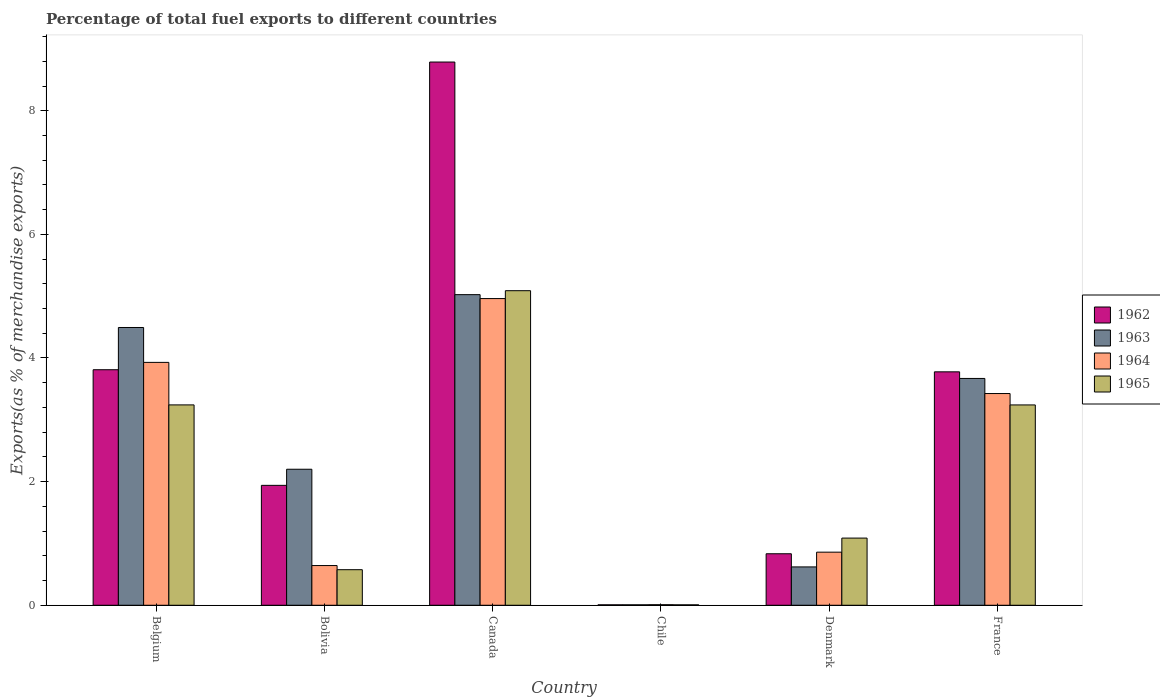How many groups of bars are there?
Offer a very short reply. 6. How many bars are there on the 1st tick from the left?
Provide a succinct answer. 4. What is the label of the 3rd group of bars from the left?
Offer a terse response. Canada. In how many cases, is the number of bars for a given country not equal to the number of legend labels?
Offer a terse response. 0. What is the percentage of exports to different countries in 1963 in France?
Provide a succinct answer. 3.67. Across all countries, what is the maximum percentage of exports to different countries in 1965?
Give a very brief answer. 5.09. Across all countries, what is the minimum percentage of exports to different countries in 1965?
Offer a terse response. 0.01. What is the total percentage of exports to different countries in 1965 in the graph?
Your response must be concise. 13.24. What is the difference between the percentage of exports to different countries in 1962 in Belgium and that in Chile?
Provide a short and direct response. 3.8. What is the difference between the percentage of exports to different countries in 1962 in Canada and the percentage of exports to different countries in 1965 in France?
Ensure brevity in your answer.  5.55. What is the average percentage of exports to different countries in 1965 per country?
Make the answer very short. 2.21. What is the difference between the percentage of exports to different countries of/in 1965 and percentage of exports to different countries of/in 1962 in Chile?
Offer a terse response. -0. In how many countries, is the percentage of exports to different countries in 1963 greater than 4.8 %?
Keep it short and to the point. 1. What is the ratio of the percentage of exports to different countries in 1964 in Chile to that in France?
Give a very brief answer. 0. Is the difference between the percentage of exports to different countries in 1965 in Bolivia and Denmark greater than the difference between the percentage of exports to different countries in 1962 in Bolivia and Denmark?
Ensure brevity in your answer.  No. What is the difference between the highest and the second highest percentage of exports to different countries in 1964?
Give a very brief answer. -0.5. What is the difference between the highest and the lowest percentage of exports to different countries in 1963?
Offer a very short reply. 5.02. What does the 2nd bar from the left in Bolivia represents?
Provide a succinct answer. 1963. What does the 2nd bar from the right in Bolivia represents?
Your response must be concise. 1964. Is it the case that in every country, the sum of the percentage of exports to different countries in 1962 and percentage of exports to different countries in 1964 is greater than the percentage of exports to different countries in 1965?
Ensure brevity in your answer.  Yes. How many bars are there?
Your answer should be very brief. 24. Are all the bars in the graph horizontal?
Your answer should be very brief. No. How are the legend labels stacked?
Provide a succinct answer. Vertical. What is the title of the graph?
Make the answer very short. Percentage of total fuel exports to different countries. What is the label or title of the X-axis?
Offer a very short reply. Country. What is the label or title of the Y-axis?
Your answer should be very brief. Exports(as % of merchandise exports). What is the Exports(as % of merchandise exports) of 1962 in Belgium?
Make the answer very short. 3.81. What is the Exports(as % of merchandise exports) in 1963 in Belgium?
Give a very brief answer. 4.49. What is the Exports(as % of merchandise exports) in 1964 in Belgium?
Provide a succinct answer. 3.93. What is the Exports(as % of merchandise exports) in 1965 in Belgium?
Your answer should be compact. 3.24. What is the Exports(as % of merchandise exports) in 1962 in Bolivia?
Keep it short and to the point. 1.94. What is the Exports(as % of merchandise exports) in 1963 in Bolivia?
Make the answer very short. 2.2. What is the Exports(as % of merchandise exports) of 1964 in Bolivia?
Ensure brevity in your answer.  0.64. What is the Exports(as % of merchandise exports) of 1965 in Bolivia?
Provide a short and direct response. 0.58. What is the Exports(as % of merchandise exports) in 1962 in Canada?
Keep it short and to the point. 8.79. What is the Exports(as % of merchandise exports) of 1963 in Canada?
Make the answer very short. 5.02. What is the Exports(as % of merchandise exports) in 1964 in Canada?
Your answer should be compact. 4.96. What is the Exports(as % of merchandise exports) in 1965 in Canada?
Ensure brevity in your answer.  5.09. What is the Exports(as % of merchandise exports) in 1962 in Chile?
Give a very brief answer. 0.01. What is the Exports(as % of merchandise exports) of 1963 in Chile?
Your answer should be very brief. 0.01. What is the Exports(as % of merchandise exports) of 1964 in Chile?
Provide a succinct answer. 0.01. What is the Exports(as % of merchandise exports) in 1965 in Chile?
Provide a succinct answer. 0.01. What is the Exports(as % of merchandise exports) of 1962 in Denmark?
Give a very brief answer. 0.83. What is the Exports(as % of merchandise exports) of 1963 in Denmark?
Keep it short and to the point. 0.62. What is the Exports(as % of merchandise exports) of 1964 in Denmark?
Give a very brief answer. 0.86. What is the Exports(as % of merchandise exports) in 1965 in Denmark?
Your response must be concise. 1.09. What is the Exports(as % of merchandise exports) of 1962 in France?
Make the answer very short. 3.78. What is the Exports(as % of merchandise exports) of 1963 in France?
Your answer should be very brief. 3.67. What is the Exports(as % of merchandise exports) of 1964 in France?
Give a very brief answer. 3.43. What is the Exports(as % of merchandise exports) in 1965 in France?
Ensure brevity in your answer.  3.24. Across all countries, what is the maximum Exports(as % of merchandise exports) in 1962?
Give a very brief answer. 8.79. Across all countries, what is the maximum Exports(as % of merchandise exports) in 1963?
Your answer should be compact. 5.02. Across all countries, what is the maximum Exports(as % of merchandise exports) of 1964?
Your response must be concise. 4.96. Across all countries, what is the maximum Exports(as % of merchandise exports) of 1965?
Offer a very short reply. 5.09. Across all countries, what is the minimum Exports(as % of merchandise exports) of 1962?
Provide a short and direct response. 0.01. Across all countries, what is the minimum Exports(as % of merchandise exports) in 1963?
Provide a succinct answer. 0.01. Across all countries, what is the minimum Exports(as % of merchandise exports) of 1964?
Your answer should be compact. 0.01. Across all countries, what is the minimum Exports(as % of merchandise exports) in 1965?
Ensure brevity in your answer.  0.01. What is the total Exports(as % of merchandise exports) of 1962 in the graph?
Offer a very short reply. 19.15. What is the total Exports(as % of merchandise exports) in 1963 in the graph?
Make the answer very short. 16.02. What is the total Exports(as % of merchandise exports) in 1964 in the graph?
Ensure brevity in your answer.  13.83. What is the total Exports(as % of merchandise exports) of 1965 in the graph?
Your response must be concise. 13.24. What is the difference between the Exports(as % of merchandise exports) in 1962 in Belgium and that in Bolivia?
Offer a terse response. 1.87. What is the difference between the Exports(as % of merchandise exports) in 1963 in Belgium and that in Bolivia?
Your response must be concise. 2.29. What is the difference between the Exports(as % of merchandise exports) of 1964 in Belgium and that in Bolivia?
Provide a succinct answer. 3.29. What is the difference between the Exports(as % of merchandise exports) of 1965 in Belgium and that in Bolivia?
Give a very brief answer. 2.67. What is the difference between the Exports(as % of merchandise exports) in 1962 in Belgium and that in Canada?
Ensure brevity in your answer.  -4.98. What is the difference between the Exports(as % of merchandise exports) of 1963 in Belgium and that in Canada?
Your answer should be very brief. -0.53. What is the difference between the Exports(as % of merchandise exports) in 1964 in Belgium and that in Canada?
Ensure brevity in your answer.  -1.03. What is the difference between the Exports(as % of merchandise exports) in 1965 in Belgium and that in Canada?
Offer a very short reply. -1.85. What is the difference between the Exports(as % of merchandise exports) of 1962 in Belgium and that in Chile?
Offer a terse response. 3.8. What is the difference between the Exports(as % of merchandise exports) in 1963 in Belgium and that in Chile?
Provide a succinct answer. 4.49. What is the difference between the Exports(as % of merchandise exports) of 1964 in Belgium and that in Chile?
Your response must be concise. 3.92. What is the difference between the Exports(as % of merchandise exports) of 1965 in Belgium and that in Chile?
Keep it short and to the point. 3.23. What is the difference between the Exports(as % of merchandise exports) in 1962 in Belgium and that in Denmark?
Give a very brief answer. 2.98. What is the difference between the Exports(as % of merchandise exports) in 1963 in Belgium and that in Denmark?
Give a very brief answer. 3.87. What is the difference between the Exports(as % of merchandise exports) in 1964 in Belgium and that in Denmark?
Offer a terse response. 3.07. What is the difference between the Exports(as % of merchandise exports) of 1965 in Belgium and that in Denmark?
Your response must be concise. 2.15. What is the difference between the Exports(as % of merchandise exports) in 1962 in Belgium and that in France?
Give a very brief answer. 0.03. What is the difference between the Exports(as % of merchandise exports) of 1963 in Belgium and that in France?
Your response must be concise. 0.82. What is the difference between the Exports(as % of merchandise exports) of 1964 in Belgium and that in France?
Keep it short and to the point. 0.5. What is the difference between the Exports(as % of merchandise exports) in 1962 in Bolivia and that in Canada?
Your answer should be very brief. -6.85. What is the difference between the Exports(as % of merchandise exports) in 1963 in Bolivia and that in Canada?
Your response must be concise. -2.82. What is the difference between the Exports(as % of merchandise exports) in 1964 in Bolivia and that in Canada?
Ensure brevity in your answer.  -4.32. What is the difference between the Exports(as % of merchandise exports) of 1965 in Bolivia and that in Canada?
Make the answer very short. -4.51. What is the difference between the Exports(as % of merchandise exports) of 1962 in Bolivia and that in Chile?
Offer a terse response. 1.93. What is the difference between the Exports(as % of merchandise exports) in 1963 in Bolivia and that in Chile?
Ensure brevity in your answer.  2.19. What is the difference between the Exports(as % of merchandise exports) in 1964 in Bolivia and that in Chile?
Make the answer very short. 0.63. What is the difference between the Exports(as % of merchandise exports) in 1965 in Bolivia and that in Chile?
Your response must be concise. 0.57. What is the difference between the Exports(as % of merchandise exports) of 1962 in Bolivia and that in Denmark?
Make the answer very short. 1.11. What is the difference between the Exports(as % of merchandise exports) of 1963 in Bolivia and that in Denmark?
Provide a succinct answer. 1.58. What is the difference between the Exports(as % of merchandise exports) of 1964 in Bolivia and that in Denmark?
Provide a succinct answer. -0.22. What is the difference between the Exports(as % of merchandise exports) of 1965 in Bolivia and that in Denmark?
Ensure brevity in your answer.  -0.51. What is the difference between the Exports(as % of merchandise exports) in 1962 in Bolivia and that in France?
Provide a succinct answer. -1.84. What is the difference between the Exports(as % of merchandise exports) in 1963 in Bolivia and that in France?
Give a very brief answer. -1.47. What is the difference between the Exports(as % of merchandise exports) of 1964 in Bolivia and that in France?
Give a very brief answer. -2.78. What is the difference between the Exports(as % of merchandise exports) in 1965 in Bolivia and that in France?
Your answer should be compact. -2.67. What is the difference between the Exports(as % of merchandise exports) in 1962 in Canada and that in Chile?
Offer a terse response. 8.78. What is the difference between the Exports(as % of merchandise exports) of 1963 in Canada and that in Chile?
Provide a short and direct response. 5.02. What is the difference between the Exports(as % of merchandise exports) of 1964 in Canada and that in Chile?
Keep it short and to the point. 4.95. What is the difference between the Exports(as % of merchandise exports) in 1965 in Canada and that in Chile?
Your response must be concise. 5.08. What is the difference between the Exports(as % of merchandise exports) in 1962 in Canada and that in Denmark?
Ensure brevity in your answer.  7.95. What is the difference between the Exports(as % of merchandise exports) in 1963 in Canada and that in Denmark?
Provide a succinct answer. 4.4. What is the difference between the Exports(as % of merchandise exports) in 1964 in Canada and that in Denmark?
Your answer should be compact. 4.1. What is the difference between the Exports(as % of merchandise exports) in 1965 in Canada and that in Denmark?
Provide a succinct answer. 4. What is the difference between the Exports(as % of merchandise exports) in 1962 in Canada and that in France?
Your answer should be very brief. 5.01. What is the difference between the Exports(as % of merchandise exports) in 1963 in Canada and that in France?
Make the answer very short. 1.36. What is the difference between the Exports(as % of merchandise exports) of 1964 in Canada and that in France?
Provide a succinct answer. 1.54. What is the difference between the Exports(as % of merchandise exports) in 1965 in Canada and that in France?
Your response must be concise. 1.85. What is the difference between the Exports(as % of merchandise exports) in 1962 in Chile and that in Denmark?
Keep it short and to the point. -0.83. What is the difference between the Exports(as % of merchandise exports) in 1963 in Chile and that in Denmark?
Ensure brevity in your answer.  -0.61. What is the difference between the Exports(as % of merchandise exports) in 1964 in Chile and that in Denmark?
Provide a succinct answer. -0.85. What is the difference between the Exports(as % of merchandise exports) in 1965 in Chile and that in Denmark?
Ensure brevity in your answer.  -1.08. What is the difference between the Exports(as % of merchandise exports) of 1962 in Chile and that in France?
Make the answer very short. -3.77. What is the difference between the Exports(as % of merchandise exports) in 1963 in Chile and that in France?
Give a very brief answer. -3.66. What is the difference between the Exports(as % of merchandise exports) of 1964 in Chile and that in France?
Give a very brief answer. -3.42. What is the difference between the Exports(as % of merchandise exports) of 1965 in Chile and that in France?
Your answer should be compact. -3.23. What is the difference between the Exports(as % of merchandise exports) of 1962 in Denmark and that in France?
Your answer should be very brief. -2.94. What is the difference between the Exports(as % of merchandise exports) of 1963 in Denmark and that in France?
Give a very brief answer. -3.05. What is the difference between the Exports(as % of merchandise exports) of 1964 in Denmark and that in France?
Provide a succinct answer. -2.57. What is the difference between the Exports(as % of merchandise exports) of 1965 in Denmark and that in France?
Offer a very short reply. -2.15. What is the difference between the Exports(as % of merchandise exports) of 1962 in Belgium and the Exports(as % of merchandise exports) of 1963 in Bolivia?
Ensure brevity in your answer.  1.61. What is the difference between the Exports(as % of merchandise exports) of 1962 in Belgium and the Exports(as % of merchandise exports) of 1964 in Bolivia?
Provide a short and direct response. 3.17. What is the difference between the Exports(as % of merchandise exports) in 1962 in Belgium and the Exports(as % of merchandise exports) in 1965 in Bolivia?
Provide a succinct answer. 3.23. What is the difference between the Exports(as % of merchandise exports) in 1963 in Belgium and the Exports(as % of merchandise exports) in 1964 in Bolivia?
Your answer should be compact. 3.85. What is the difference between the Exports(as % of merchandise exports) of 1963 in Belgium and the Exports(as % of merchandise exports) of 1965 in Bolivia?
Your answer should be very brief. 3.92. What is the difference between the Exports(as % of merchandise exports) of 1964 in Belgium and the Exports(as % of merchandise exports) of 1965 in Bolivia?
Your answer should be very brief. 3.35. What is the difference between the Exports(as % of merchandise exports) of 1962 in Belgium and the Exports(as % of merchandise exports) of 1963 in Canada?
Your answer should be very brief. -1.21. What is the difference between the Exports(as % of merchandise exports) of 1962 in Belgium and the Exports(as % of merchandise exports) of 1964 in Canada?
Your response must be concise. -1.15. What is the difference between the Exports(as % of merchandise exports) in 1962 in Belgium and the Exports(as % of merchandise exports) in 1965 in Canada?
Offer a very short reply. -1.28. What is the difference between the Exports(as % of merchandise exports) in 1963 in Belgium and the Exports(as % of merchandise exports) in 1964 in Canada?
Your response must be concise. -0.47. What is the difference between the Exports(as % of merchandise exports) in 1963 in Belgium and the Exports(as % of merchandise exports) in 1965 in Canada?
Provide a succinct answer. -0.6. What is the difference between the Exports(as % of merchandise exports) in 1964 in Belgium and the Exports(as % of merchandise exports) in 1965 in Canada?
Provide a short and direct response. -1.16. What is the difference between the Exports(as % of merchandise exports) of 1962 in Belgium and the Exports(as % of merchandise exports) of 1963 in Chile?
Your answer should be very brief. 3.8. What is the difference between the Exports(as % of merchandise exports) in 1962 in Belgium and the Exports(as % of merchandise exports) in 1964 in Chile?
Offer a very short reply. 3.8. What is the difference between the Exports(as % of merchandise exports) in 1962 in Belgium and the Exports(as % of merchandise exports) in 1965 in Chile?
Make the answer very short. 3.8. What is the difference between the Exports(as % of merchandise exports) in 1963 in Belgium and the Exports(as % of merchandise exports) in 1964 in Chile?
Make the answer very short. 4.48. What is the difference between the Exports(as % of merchandise exports) of 1963 in Belgium and the Exports(as % of merchandise exports) of 1965 in Chile?
Offer a very short reply. 4.49. What is the difference between the Exports(as % of merchandise exports) in 1964 in Belgium and the Exports(as % of merchandise exports) in 1965 in Chile?
Your response must be concise. 3.92. What is the difference between the Exports(as % of merchandise exports) of 1962 in Belgium and the Exports(as % of merchandise exports) of 1963 in Denmark?
Provide a short and direct response. 3.19. What is the difference between the Exports(as % of merchandise exports) of 1962 in Belgium and the Exports(as % of merchandise exports) of 1964 in Denmark?
Offer a very short reply. 2.95. What is the difference between the Exports(as % of merchandise exports) of 1962 in Belgium and the Exports(as % of merchandise exports) of 1965 in Denmark?
Your response must be concise. 2.72. What is the difference between the Exports(as % of merchandise exports) in 1963 in Belgium and the Exports(as % of merchandise exports) in 1964 in Denmark?
Provide a short and direct response. 3.63. What is the difference between the Exports(as % of merchandise exports) in 1963 in Belgium and the Exports(as % of merchandise exports) in 1965 in Denmark?
Your answer should be compact. 3.41. What is the difference between the Exports(as % of merchandise exports) in 1964 in Belgium and the Exports(as % of merchandise exports) in 1965 in Denmark?
Your response must be concise. 2.84. What is the difference between the Exports(as % of merchandise exports) in 1962 in Belgium and the Exports(as % of merchandise exports) in 1963 in France?
Offer a terse response. 0.14. What is the difference between the Exports(as % of merchandise exports) of 1962 in Belgium and the Exports(as % of merchandise exports) of 1964 in France?
Offer a terse response. 0.39. What is the difference between the Exports(as % of merchandise exports) in 1962 in Belgium and the Exports(as % of merchandise exports) in 1965 in France?
Ensure brevity in your answer.  0.57. What is the difference between the Exports(as % of merchandise exports) of 1963 in Belgium and the Exports(as % of merchandise exports) of 1964 in France?
Offer a terse response. 1.07. What is the difference between the Exports(as % of merchandise exports) in 1963 in Belgium and the Exports(as % of merchandise exports) in 1965 in France?
Your answer should be very brief. 1.25. What is the difference between the Exports(as % of merchandise exports) of 1964 in Belgium and the Exports(as % of merchandise exports) of 1965 in France?
Offer a very short reply. 0.69. What is the difference between the Exports(as % of merchandise exports) in 1962 in Bolivia and the Exports(as % of merchandise exports) in 1963 in Canada?
Keep it short and to the point. -3.08. What is the difference between the Exports(as % of merchandise exports) in 1962 in Bolivia and the Exports(as % of merchandise exports) in 1964 in Canada?
Make the answer very short. -3.02. What is the difference between the Exports(as % of merchandise exports) of 1962 in Bolivia and the Exports(as % of merchandise exports) of 1965 in Canada?
Your response must be concise. -3.15. What is the difference between the Exports(as % of merchandise exports) in 1963 in Bolivia and the Exports(as % of merchandise exports) in 1964 in Canada?
Your answer should be very brief. -2.76. What is the difference between the Exports(as % of merchandise exports) of 1963 in Bolivia and the Exports(as % of merchandise exports) of 1965 in Canada?
Provide a succinct answer. -2.89. What is the difference between the Exports(as % of merchandise exports) in 1964 in Bolivia and the Exports(as % of merchandise exports) in 1965 in Canada?
Provide a short and direct response. -4.45. What is the difference between the Exports(as % of merchandise exports) of 1962 in Bolivia and the Exports(as % of merchandise exports) of 1963 in Chile?
Ensure brevity in your answer.  1.93. What is the difference between the Exports(as % of merchandise exports) in 1962 in Bolivia and the Exports(as % of merchandise exports) in 1964 in Chile?
Make the answer very short. 1.93. What is the difference between the Exports(as % of merchandise exports) in 1962 in Bolivia and the Exports(as % of merchandise exports) in 1965 in Chile?
Offer a terse response. 1.93. What is the difference between the Exports(as % of merchandise exports) of 1963 in Bolivia and the Exports(as % of merchandise exports) of 1964 in Chile?
Your answer should be very brief. 2.19. What is the difference between the Exports(as % of merchandise exports) of 1963 in Bolivia and the Exports(as % of merchandise exports) of 1965 in Chile?
Ensure brevity in your answer.  2.19. What is the difference between the Exports(as % of merchandise exports) in 1964 in Bolivia and the Exports(as % of merchandise exports) in 1965 in Chile?
Keep it short and to the point. 0.64. What is the difference between the Exports(as % of merchandise exports) in 1962 in Bolivia and the Exports(as % of merchandise exports) in 1963 in Denmark?
Your answer should be compact. 1.32. What is the difference between the Exports(as % of merchandise exports) in 1962 in Bolivia and the Exports(as % of merchandise exports) in 1964 in Denmark?
Give a very brief answer. 1.08. What is the difference between the Exports(as % of merchandise exports) in 1962 in Bolivia and the Exports(as % of merchandise exports) in 1965 in Denmark?
Your answer should be very brief. 0.85. What is the difference between the Exports(as % of merchandise exports) in 1963 in Bolivia and the Exports(as % of merchandise exports) in 1964 in Denmark?
Provide a short and direct response. 1.34. What is the difference between the Exports(as % of merchandise exports) in 1963 in Bolivia and the Exports(as % of merchandise exports) in 1965 in Denmark?
Your answer should be compact. 1.11. What is the difference between the Exports(as % of merchandise exports) in 1964 in Bolivia and the Exports(as % of merchandise exports) in 1965 in Denmark?
Your answer should be very brief. -0.44. What is the difference between the Exports(as % of merchandise exports) of 1962 in Bolivia and the Exports(as % of merchandise exports) of 1963 in France?
Provide a short and direct response. -1.73. What is the difference between the Exports(as % of merchandise exports) of 1962 in Bolivia and the Exports(as % of merchandise exports) of 1964 in France?
Your answer should be very brief. -1.49. What is the difference between the Exports(as % of merchandise exports) of 1962 in Bolivia and the Exports(as % of merchandise exports) of 1965 in France?
Offer a very short reply. -1.3. What is the difference between the Exports(as % of merchandise exports) in 1963 in Bolivia and the Exports(as % of merchandise exports) in 1964 in France?
Keep it short and to the point. -1.22. What is the difference between the Exports(as % of merchandise exports) of 1963 in Bolivia and the Exports(as % of merchandise exports) of 1965 in France?
Offer a very short reply. -1.04. What is the difference between the Exports(as % of merchandise exports) of 1964 in Bolivia and the Exports(as % of merchandise exports) of 1965 in France?
Your response must be concise. -2.6. What is the difference between the Exports(as % of merchandise exports) of 1962 in Canada and the Exports(as % of merchandise exports) of 1963 in Chile?
Give a very brief answer. 8.78. What is the difference between the Exports(as % of merchandise exports) of 1962 in Canada and the Exports(as % of merchandise exports) of 1964 in Chile?
Ensure brevity in your answer.  8.78. What is the difference between the Exports(as % of merchandise exports) in 1962 in Canada and the Exports(as % of merchandise exports) in 1965 in Chile?
Provide a short and direct response. 8.78. What is the difference between the Exports(as % of merchandise exports) in 1963 in Canada and the Exports(as % of merchandise exports) in 1964 in Chile?
Provide a succinct answer. 5.02. What is the difference between the Exports(as % of merchandise exports) of 1963 in Canada and the Exports(as % of merchandise exports) of 1965 in Chile?
Provide a short and direct response. 5.02. What is the difference between the Exports(as % of merchandise exports) of 1964 in Canada and the Exports(as % of merchandise exports) of 1965 in Chile?
Make the answer very short. 4.95. What is the difference between the Exports(as % of merchandise exports) of 1962 in Canada and the Exports(as % of merchandise exports) of 1963 in Denmark?
Offer a very short reply. 8.17. What is the difference between the Exports(as % of merchandise exports) in 1962 in Canada and the Exports(as % of merchandise exports) in 1964 in Denmark?
Provide a short and direct response. 7.93. What is the difference between the Exports(as % of merchandise exports) of 1962 in Canada and the Exports(as % of merchandise exports) of 1965 in Denmark?
Keep it short and to the point. 7.7. What is the difference between the Exports(as % of merchandise exports) of 1963 in Canada and the Exports(as % of merchandise exports) of 1964 in Denmark?
Make the answer very short. 4.17. What is the difference between the Exports(as % of merchandise exports) of 1963 in Canada and the Exports(as % of merchandise exports) of 1965 in Denmark?
Your answer should be compact. 3.94. What is the difference between the Exports(as % of merchandise exports) in 1964 in Canada and the Exports(as % of merchandise exports) in 1965 in Denmark?
Make the answer very short. 3.87. What is the difference between the Exports(as % of merchandise exports) in 1962 in Canada and the Exports(as % of merchandise exports) in 1963 in France?
Your answer should be very brief. 5.12. What is the difference between the Exports(as % of merchandise exports) in 1962 in Canada and the Exports(as % of merchandise exports) in 1964 in France?
Provide a succinct answer. 5.36. What is the difference between the Exports(as % of merchandise exports) in 1962 in Canada and the Exports(as % of merchandise exports) in 1965 in France?
Provide a short and direct response. 5.55. What is the difference between the Exports(as % of merchandise exports) of 1963 in Canada and the Exports(as % of merchandise exports) of 1964 in France?
Give a very brief answer. 1.6. What is the difference between the Exports(as % of merchandise exports) of 1963 in Canada and the Exports(as % of merchandise exports) of 1965 in France?
Your response must be concise. 1.78. What is the difference between the Exports(as % of merchandise exports) of 1964 in Canada and the Exports(as % of merchandise exports) of 1965 in France?
Keep it short and to the point. 1.72. What is the difference between the Exports(as % of merchandise exports) of 1962 in Chile and the Exports(as % of merchandise exports) of 1963 in Denmark?
Your answer should be very brief. -0.61. What is the difference between the Exports(as % of merchandise exports) of 1962 in Chile and the Exports(as % of merchandise exports) of 1964 in Denmark?
Offer a terse response. -0.85. What is the difference between the Exports(as % of merchandise exports) in 1962 in Chile and the Exports(as % of merchandise exports) in 1965 in Denmark?
Offer a terse response. -1.08. What is the difference between the Exports(as % of merchandise exports) of 1963 in Chile and the Exports(as % of merchandise exports) of 1964 in Denmark?
Give a very brief answer. -0.85. What is the difference between the Exports(as % of merchandise exports) of 1963 in Chile and the Exports(as % of merchandise exports) of 1965 in Denmark?
Keep it short and to the point. -1.08. What is the difference between the Exports(as % of merchandise exports) of 1964 in Chile and the Exports(as % of merchandise exports) of 1965 in Denmark?
Offer a very short reply. -1.08. What is the difference between the Exports(as % of merchandise exports) of 1962 in Chile and the Exports(as % of merchandise exports) of 1963 in France?
Keep it short and to the point. -3.66. What is the difference between the Exports(as % of merchandise exports) of 1962 in Chile and the Exports(as % of merchandise exports) of 1964 in France?
Ensure brevity in your answer.  -3.42. What is the difference between the Exports(as % of merchandise exports) of 1962 in Chile and the Exports(as % of merchandise exports) of 1965 in France?
Provide a short and direct response. -3.23. What is the difference between the Exports(as % of merchandise exports) of 1963 in Chile and the Exports(as % of merchandise exports) of 1964 in France?
Provide a short and direct response. -3.42. What is the difference between the Exports(as % of merchandise exports) in 1963 in Chile and the Exports(as % of merchandise exports) in 1965 in France?
Keep it short and to the point. -3.23. What is the difference between the Exports(as % of merchandise exports) in 1964 in Chile and the Exports(as % of merchandise exports) in 1965 in France?
Offer a terse response. -3.23. What is the difference between the Exports(as % of merchandise exports) of 1962 in Denmark and the Exports(as % of merchandise exports) of 1963 in France?
Your response must be concise. -2.84. What is the difference between the Exports(as % of merchandise exports) of 1962 in Denmark and the Exports(as % of merchandise exports) of 1964 in France?
Give a very brief answer. -2.59. What is the difference between the Exports(as % of merchandise exports) of 1962 in Denmark and the Exports(as % of merchandise exports) of 1965 in France?
Your answer should be compact. -2.41. What is the difference between the Exports(as % of merchandise exports) of 1963 in Denmark and the Exports(as % of merchandise exports) of 1964 in France?
Provide a short and direct response. -2.8. What is the difference between the Exports(as % of merchandise exports) of 1963 in Denmark and the Exports(as % of merchandise exports) of 1965 in France?
Ensure brevity in your answer.  -2.62. What is the difference between the Exports(as % of merchandise exports) in 1964 in Denmark and the Exports(as % of merchandise exports) in 1965 in France?
Offer a very short reply. -2.38. What is the average Exports(as % of merchandise exports) of 1962 per country?
Keep it short and to the point. 3.19. What is the average Exports(as % of merchandise exports) in 1963 per country?
Ensure brevity in your answer.  2.67. What is the average Exports(as % of merchandise exports) of 1964 per country?
Keep it short and to the point. 2.3. What is the average Exports(as % of merchandise exports) of 1965 per country?
Ensure brevity in your answer.  2.21. What is the difference between the Exports(as % of merchandise exports) of 1962 and Exports(as % of merchandise exports) of 1963 in Belgium?
Ensure brevity in your answer.  -0.68. What is the difference between the Exports(as % of merchandise exports) in 1962 and Exports(as % of merchandise exports) in 1964 in Belgium?
Offer a very short reply. -0.12. What is the difference between the Exports(as % of merchandise exports) in 1962 and Exports(as % of merchandise exports) in 1965 in Belgium?
Make the answer very short. 0.57. What is the difference between the Exports(as % of merchandise exports) of 1963 and Exports(as % of merchandise exports) of 1964 in Belgium?
Provide a short and direct response. 0.56. What is the difference between the Exports(as % of merchandise exports) of 1963 and Exports(as % of merchandise exports) of 1965 in Belgium?
Offer a very short reply. 1.25. What is the difference between the Exports(as % of merchandise exports) in 1964 and Exports(as % of merchandise exports) in 1965 in Belgium?
Make the answer very short. 0.69. What is the difference between the Exports(as % of merchandise exports) in 1962 and Exports(as % of merchandise exports) in 1963 in Bolivia?
Make the answer very short. -0.26. What is the difference between the Exports(as % of merchandise exports) in 1962 and Exports(as % of merchandise exports) in 1964 in Bolivia?
Give a very brief answer. 1.3. What is the difference between the Exports(as % of merchandise exports) of 1962 and Exports(as % of merchandise exports) of 1965 in Bolivia?
Your answer should be very brief. 1.36. What is the difference between the Exports(as % of merchandise exports) in 1963 and Exports(as % of merchandise exports) in 1964 in Bolivia?
Keep it short and to the point. 1.56. What is the difference between the Exports(as % of merchandise exports) of 1963 and Exports(as % of merchandise exports) of 1965 in Bolivia?
Your answer should be very brief. 1.62. What is the difference between the Exports(as % of merchandise exports) of 1964 and Exports(as % of merchandise exports) of 1965 in Bolivia?
Offer a very short reply. 0.07. What is the difference between the Exports(as % of merchandise exports) of 1962 and Exports(as % of merchandise exports) of 1963 in Canada?
Make the answer very short. 3.76. What is the difference between the Exports(as % of merchandise exports) in 1962 and Exports(as % of merchandise exports) in 1964 in Canada?
Offer a terse response. 3.83. What is the difference between the Exports(as % of merchandise exports) of 1962 and Exports(as % of merchandise exports) of 1965 in Canada?
Provide a succinct answer. 3.7. What is the difference between the Exports(as % of merchandise exports) of 1963 and Exports(as % of merchandise exports) of 1964 in Canada?
Your answer should be compact. 0.06. What is the difference between the Exports(as % of merchandise exports) in 1963 and Exports(as % of merchandise exports) in 1965 in Canada?
Offer a terse response. -0.06. What is the difference between the Exports(as % of merchandise exports) in 1964 and Exports(as % of merchandise exports) in 1965 in Canada?
Keep it short and to the point. -0.13. What is the difference between the Exports(as % of merchandise exports) in 1962 and Exports(as % of merchandise exports) in 1963 in Chile?
Your answer should be very brief. -0. What is the difference between the Exports(as % of merchandise exports) in 1962 and Exports(as % of merchandise exports) in 1964 in Chile?
Make the answer very short. -0. What is the difference between the Exports(as % of merchandise exports) of 1962 and Exports(as % of merchandise exports) of 1965 in Chile?
Ensure brevity in your answer.  0. What is the difference between the Exports(as % of merchandise exports) of 1963 and Exports(as % of merchandise exports) of 1964 in Chile?
Ensure brevity in your answer.  -0. What is the difference between the Exports(as % of merchandise exports) in 1963 and Exports(as % of merchandise exports) in 1965 in Chile?
Make the answer very short. 0. What is the difference between the Exports(as % of merchandise exports) of 1964 and Exports(as % of merchandise exports) of 1965 in Chile?
Your answer should be compact. 0. What is the difference between the Exports(as % of merchandise exports) of 1962 and Exports(as % of merchandise exports) of 1963 in Denmark?
Provide a succinct answer. 0.21. What is the difference between the Exports(as % of merchandise exports) in 1962 and Exports(as % of merchandise exports) in 1964 in Denmark?
Keep it short and to the point. -0.03. What is the difference between the Exports(as % of merchandise exports) of 1962 and Exports(as % of merchandise exports) of 1965 in Denmark?
Keep it short and to the point. -0.25. What is the difference between the Exports(as % of merchandise exports) in 1963 and Exports(as % of merchandise exports) in 1964 in Denmark?
Give a very brief answer. -0.24. What is the difference between the Exports(as % of merchandise exports) of 1963 and Exports(as % of merchandise exports) of 1965 in Denmark?
Ensure brevity in your answer.  -0.47. What is the difference between the Exports(as % of merchandise exports) of 1964 and Exports(as % of merchandise exports) of 1965 in Denmark?
Give a very brief answer. -0.23. What is the difference between the Exports(as % of merchandise exports) of 1962 and Exports(as % of merchandise exports) of 1963 in France?
Provide a succinct answer. 0.11. What is the difference between the Exports(as % of merchandise exports) of 1962 and Exports(as % of merchandise exports) of 1964 in France?
Provide a succinct answer. 0.35. What is the difference between the Exports(as % of merchandise exports) in 1962 and Exports(as % of merchandise exports) in 1965 in France?
Your response must be concise. 0.54. What is the difference between the Exports(as % of merchandise exports) in 1963 and Exports(as % of merchandise exports) in 1964 in France?
Your answer should be very brief. 0.24. What is the difference between the Exports(as % of merchandise exports) in 1963 and Exports(as % of merchandise exports) in 1965 in France?
Offer a terse response. 0.43. What is the difference between the Exports(as % of merchandise exports) in 1964 and Exports(as % of merchandise exports) in 1965 in France?
Give a very brief answer. 0.18. What is the ratio of the Exports(as % of merchandise exports) in 1962 in Belgium to that in Bolivia?
Your answer should be very brief. 1.96. What is the ratio of the Exports(as % of merchandise exports) in 1963 in Belgium to that in Bolivia?
Offer a very short reply. 2.04. What is the ratio of the Exports(as % of merchandise exports) in 1964 in Belgium to that in Bolivia?
Offer a terse response. 6.12. What is the ratio of the Exports(as % of merchandise exports) in 1965 in Belgium to that in Bolivia?
Ensure brevity in your answer.  5.63. What is the ratio of the Exports(as % of merchandise exports) in 1962 in Belgium to that in Canada?
Offer a very short reply. 0.43. What is the ratio of the Exports(as % of merchandise exports) of 1963 in Belgium to that in Canada?
Make the answer very short. 0.89. What is the ratio of the Exports(as % of merchandise exports) of 1964 in Belgium to that in Canada?
Offer a very short reply. 0.79. What is the ratio of the Exports(as % of merchandise exports) in 1965 in Belgium to that in Canada?
Your answer should be compact. 0.64. What is the ratio of the Exports(as % of merchandise exports) of 1962 in Belgium to that in Chile?
Your response must be concise. 543.89. What is the ratio of the Exports(as % of merchandise exports) in 1963 in Belgium to that in Chile?
Your answer should be compact. 634.23. What is the ratio of the Exports(as % of merchandise exports) of 1964 in Belgium to that in Chile?
Keep it short and to the point. 439.88. What is the ratio of the Exports(as % of merchandise exports) of 1965 in Belgium to that in Chile?
Provide a succinct answer. 479.5. What is the ratio of the Exports(as % of merchandise exports) of 1962 in Belgium to that in Denmark?
Offer a very short reply. 4.57. What is the ratio of the Exports(as % of merchandise exports) of 1963 in Belgium to that in Denmark?
Give a very brief answer. 7.24. What is the ratio of the Exports(as % of merchandise exports) of 1964 in Belgium to that in Denmark?
Your answer should be very brief. 4.57. What is the ratio of the Exports(as % of merchandise exports) in 1965 in Belgium to that in Denmark?
Provide a short and direct response. 2.98. What is the ratio of the Exports(as % of merchandise exports) in 1962 in Belgium to that in France?
Provide a short and direct response. 1.01. What is the ratio of the Exports(as % of merchandise exports) of 1963 in Belgium to that in France?
Your answer should be compact. 1.22. What is the ratio of the Exports(as % of merchandise exports) in 1964 in Belgium to that in France?
Make the answer very short. 1.15. What is the ratio of the Exports(as % of merchandise exports) of 1962 in Bolivia to that in Canada?
Keep it short and to the point. 0.22. What is the ratio of the Exports(as % of merchandise exports) of 1963 in Bolivia to that in Canada?
Your answer should be compact. 0.44. What is the ratio of the Exports(as % of merchandise exports) in 1964 in Bolivia to that in Canada?
Your answer should be compact. 0.13. What is the ratio of the Exports(as % of merchandise exports) in 1965 in Bolivia to that in Canada?
Give a very brief answer. 0.11. What is the ratio of the Exports(as % of merchandise exports) of 1962 in Bolivia to that in Chile?
Your answer should be compact. 276.87. What is the ratio of the Exports(as % of merchandise exports) in 1963 in Bolivia to that in Chile?
Make the answer very short. 310.59. What is the ratio of the Exports(as % of merchandise exports) in 1964 in Bolivia to that in Chile?
Your response must be concise. 71.92. What is the ratio of the Exports(as % of merchandise exports) of 1965 in Bolivia to that in Chile?
Your answer should be very brief. 85.13. What is the ratio of the Exports(as % of merchandise exports) in 1962 in Bolivia to that in Denmark?
Your response must be concise. 2.33. What is the ratio of the Exports(as % of merchandise exports) in 1963 in Bolivia to that in Denmark?
Provide a succinct answer. 3.55. What is the ratio of the Exports(as % of merchandise exports) of 1964 in Bolivia to that in Denmark?
Keep it short and to the point. 0.75. What is the ratio of the Exports(as % of merchandise exports) in 1965 in Bolivia to that in Denmark?
Your response must be concise. 0.53. What is the ratio of the Exports(as % of merchandise exports) of 1962 in Bolivia to that in France?
Your answer should be compact. 0.51. What is the ratio of the Exports(as % of merchandise exports) in 1963 in Bolivia to that in France?
Keep it short and to the point. 0.6. What is the ratio of the Exports(as % of merchandise exports) of 1964 in Bolivia to that in France?
Offer a very short reply. 0.19. What is the ratio of the Exports(as % of merchandise exports) in 1965 in Bolivia to that in France?
Keep it short and to the point. 0.18. What is the ratio of the Exports(as % of merchandise exports) of 1962 in Canada to that in Chile?
Provide a short and direct response. 1254.38. What is the ratio of the Exports(as % of merchandise exports) in 1963 in Canada to that in Chile?
Ensure brevity in your answer.  709.22. What is the ratio of the Exports(as % of merchandise exports) of 1964 in Canada to that in Chile?
Make the answer very short. 555.45. What is the ratio of the Exports(as % of merchandise exports) in 1965 in Canada to that in Chile?
Offer a terse response. 752.83. What is the ratio of the Exports(as % of merchandise exports) of 1962 in Canada to that in Denmark?
Your answer should be very brief. 10.55. What is the ratio of the Exports(as % of merchandise exports) in 1963 in Canada to that in Denmark?
Keep it short and to the point. 8.1. What is the ratio of the Exports(as % of merchandise exports) in 1964 in Canada to that in Denmark?
Keep it short and to the point. 5.78. What is the ratio of the Exports(as % of merchandise exports) of 1965 in Canada to that in Denmark?
Your response must be concise. 4.68. What is the ratio of the Exports(as % of merchandise exports) of 1962 in Canada to that in France?
Offer a terse response. 2.33. What is the ratio of the Exports(as % of merchandise exports) in 1963 in Canada to that in France?
Provide a succinct answer. 1.37. What is the ratio of the Exports(as % of merchandise exports) in 1964 in Canada to that in France?
Your response must be concise. 1.45. What is the ratio of the Exports(as % of merchandise exports) in 1965 in Canada to that in France?
Provide a short and direct response. 1.57. What is the ratio of the Exports(as % of merchandise exports) in 1962 in Chile to that in Denmark?
Offer a very short reply. 0.01. What is the ratio of the Exports(as % of merchandise exports) in 1963 in Chile to that in Denmark?
Provide a succinct answer. 0.01. What is the ratio of the Exports(as % of merchandise exports) in 1964 in Chile to that in Denmark?
Provide a short and direct response. 0.01. What is the ratio of the Exports(as % of merchandise exports) of 1965 in Chile to that in Denmark?
Ensure brevity in your answer.  0.01. What is the ratio of the Exports(as % of merchandise exports) in 1962 in Chile to that in France?
Keep it short and to the point. 0. What is the ratio of the Exports(as % of merchandise exports) in 1963 in Chile to that in France?
Your answer should be compact. 0. What is the ratio of the Exports(as % of merchandise exports) of 1964 in Chile to that in France?
Keep it short and to the point. 0. What is the ratio of the Exports(as % of merchandise exports) of 1965 in Chile to that in France?
Give a very brief answer. 0. What is the ratio of the Exports(as % of merchandise exports) in 1962 in Denmark to that in France?
Provide a short and direct response. 0.22. What is the ratio of the Exports(as % of merchandise exports) in 1963 in Denmark to that in France?
Keep it short and to the point. 0.17. What is the ratio of the Exports(as % of merchandise exports) in 1964 in Denmark to that in France?
Offer a terse response. 0.25. What is the ratio of the Exports(as % of merchandise exports) of 1965 in Denmark to that in France?
Give a very brief answer. 0.34. What is the difference between the highest and the second highest Exports(as % of merchandise exports) in 1962?
Offer a very short reply. 4.98. What is the difference between the highest and the second highest Exports(as % of merchandise exports) in 1963?
Offer a very short reply. 0.53. What is the difference between the highest and the second highest Exports(as % of merchandise exports) in 1964?
Your answer should be very brief. 1.03. What is the difference between the highest and the second highest Exports(as % of merchandise exports) of 1965?
Ensure brevity in your answer.  1.85. What is the difference between the highest and the lowest Exports(as % of merchandise exports) of 1962?
Provide a short and direct response. 8.78. What is the difference between the highest and the lowest Exports(as % of merchandise exports) in 1963?
Give a very brief answer. 5.02. What is the difference between the highest and the lowest Exports(as % of merchandise exports) in 1964?
Provide a short and direct response. 4.95. What is the difference between the highest and the lowest Exports(as % of merchandise exports) in 1965?
Your answer should be compact. 5.08. 